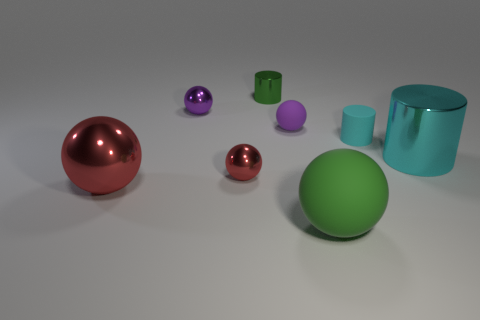Subtract all red spheres. How many spheres are left? 3 Subtract all big cyan metal cylinders. How many cylinders are left? 2 Add 1 small purple matte objects. How many objects exist? 9 Subtract all brown cylinders. How many green spheres are left? 1 Subtract all brown cylinders. Subtract all red blocks. How many cylinders are left? 3 Subtract all matte things. Subtract all small rubber cylinders. How many objects are left? 4 Add 5 purple metal objects. How many purple metal objects are left? 6 Add 6 yellow metal cylinders. How many yellow metal cylinders exist? 6 Subtract 1 green cylinders. How many objects are left? 7 Subtract all cylinders. How many objects are left? 5 